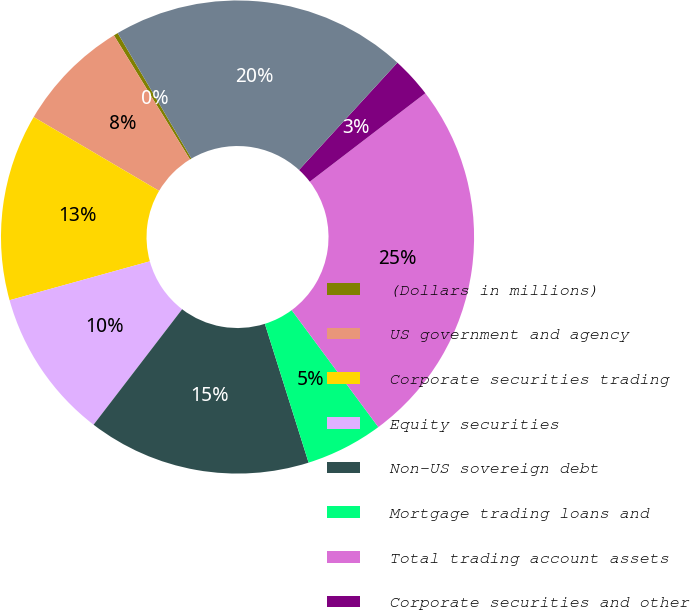Convert chart. <chart><loc_0><loc_0><loc_500><loc_500><pie_chart><fcel>(Dollars in millions)<fcel>US government and agency<fcel>Corporate securities trading<fcel>Equity securities<fcel>Non-US sovereign debt<fcel>Mortgage trading loans and<fcel>Total trading account assets<fcel>Corporate securities and other<fcel>Total trading account<nl><fcel>0.3%<fcel>7.78%<fcel>12.77%<fcel>10.28%<fcel>15.27%<fcel>5.29%<fcel>25.25%<fcel>2.79%<fcel>20.26%<nl></chart> 